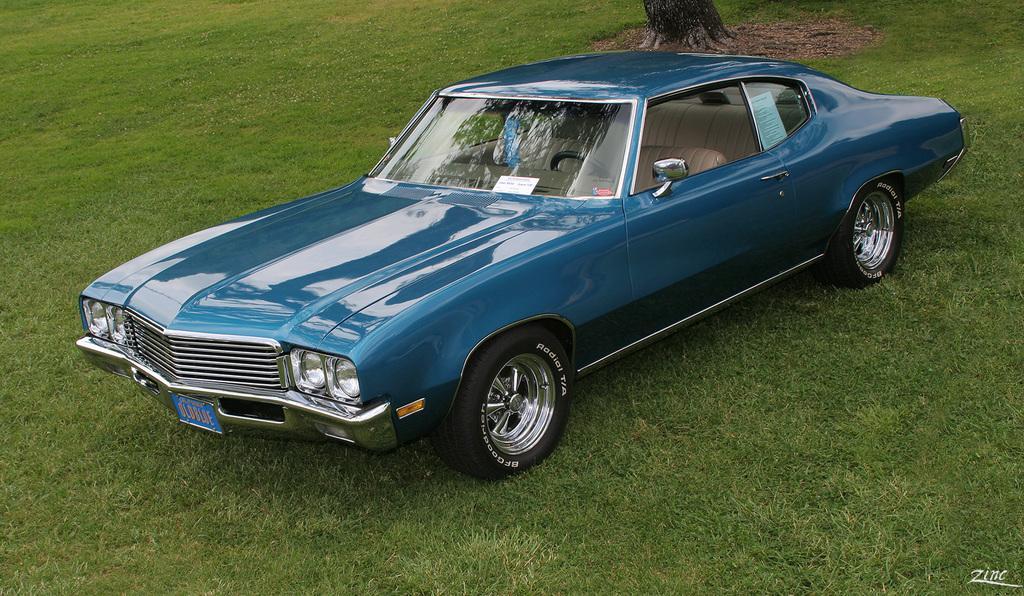Please provide a concise description of this image. In this image we can see a car, there is a trunk of a tree, also we can see the grass and text on the image. 